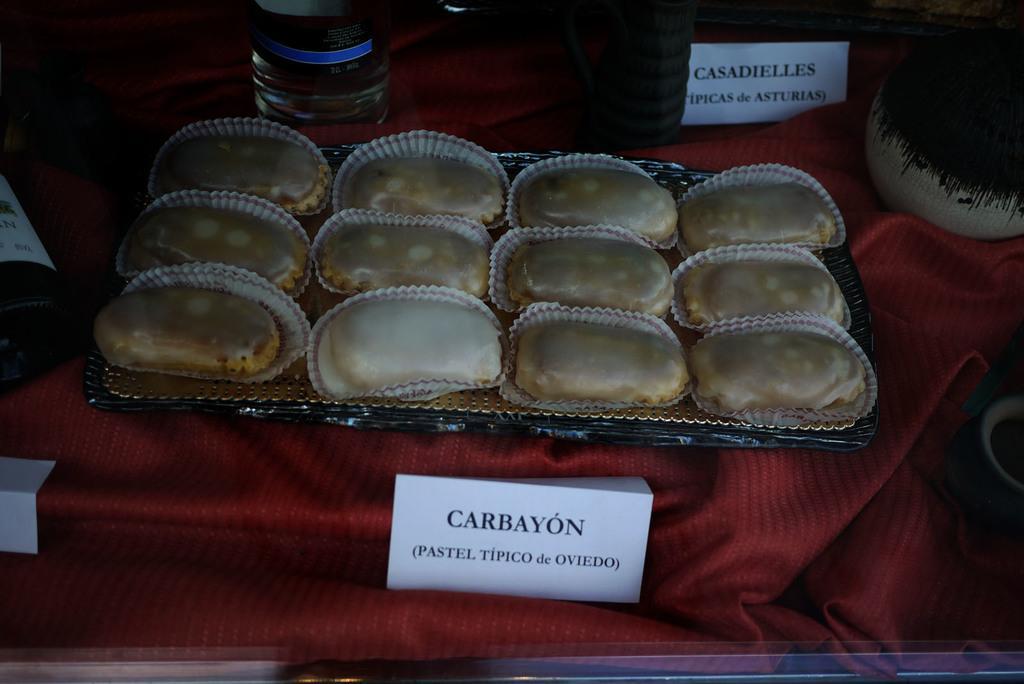Can you describe this image briefly? In this image we can see red color cloth. On that there is a tray with sweets. Also there are bottles. And there are name tags. 